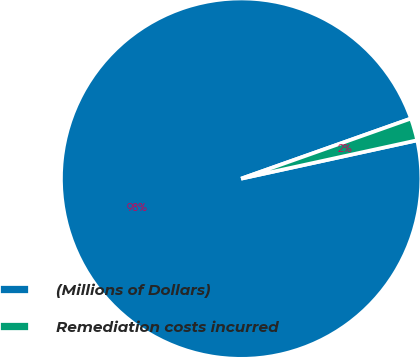Convert chart. <chart><loc_0><loc_0><loc_500><loc_500><pie_chart><fcel>(Millions of Dollars)<fcel>Remediation costs incurred<nl><fcel>98.0%<fcel>2.0%<nl></chart> 